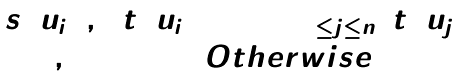<formula> <loc_0><loc_0><loc_500><loc_500>\begin{matrix} s \left ( u _ { i } \right ) , & \ t \left ( u _ { i } \right ) = \max _ { 1 \leq j \leq n } \ t \left ( u _ { j } \right ) \\ 0 , & O t h e r w i s e \end{matrix}</formula> 